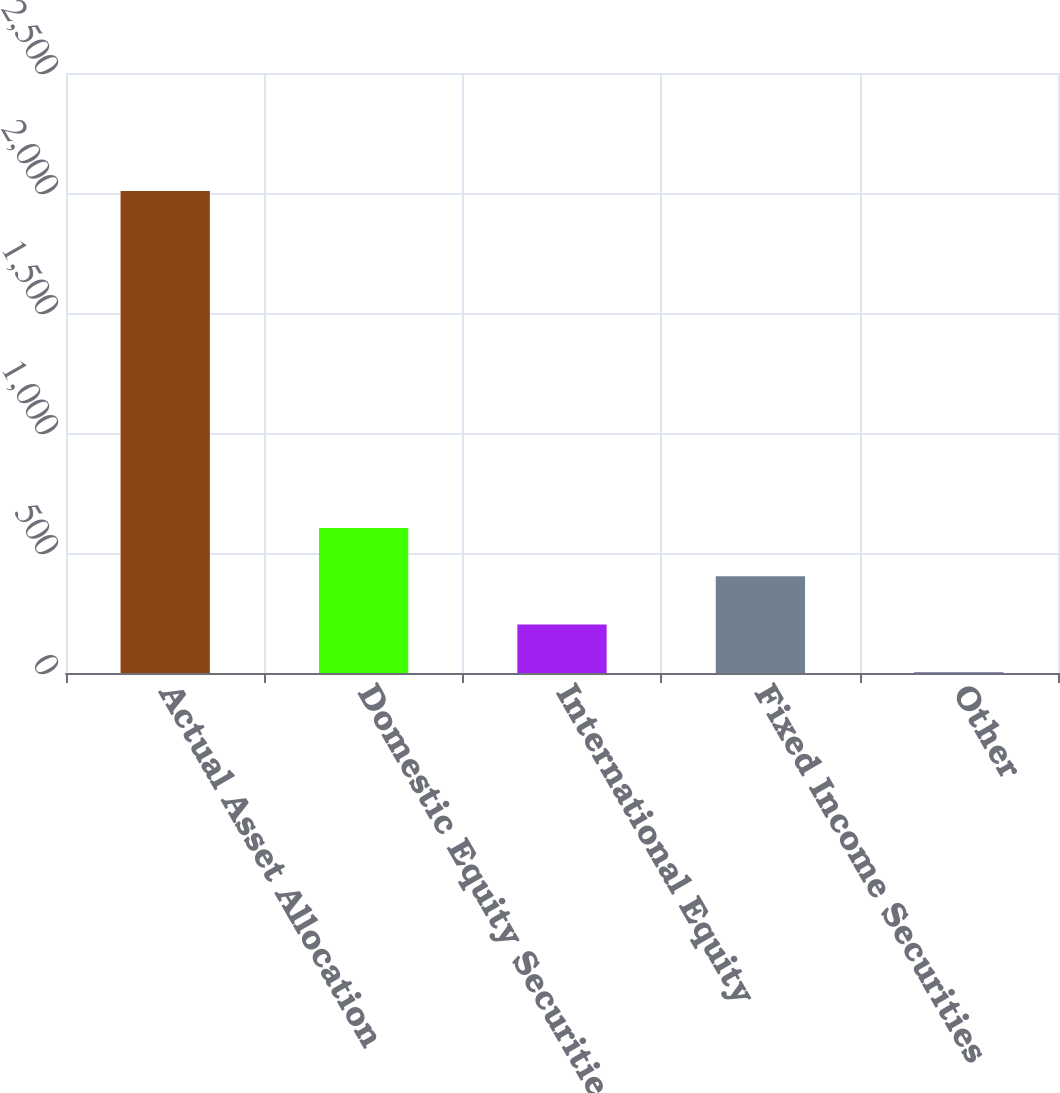Convert chart. <chart><loc_0><loc_0><loc_500><loc_500><bar_chart><fcel>Actual Asset Allocation<fcel>Domestic Equity Securities<fcel>International Equity<fcel>Fixed Income Securities<fcel>Other<nl><fcel>2008<fcel>603.8<fcel>202.6<fcel>403.2<fcel>2<nl></chart> 